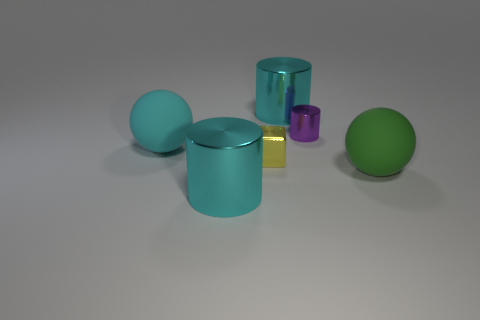Subtract all cyan cubes. Subtract all yellow cylinders. How many cubes are left? 1 Add 4 tiny yellow metal things. How many objects exist? 10 Subtract all cubes. How many objects are left? 5 Add 1 large green things. How many large green things exist? 2 Subtract 1 green spheres. How many objects are left? 5 Subtract all brown balls. Subtract all small purple things. How many objects are left? 5 Add 4 big spheres. How many big spheres are left? 6 